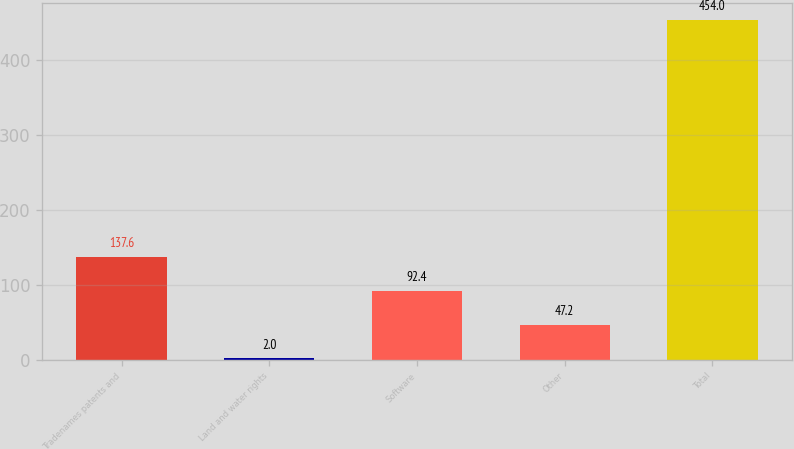Convert chart to OTSL. <chart><loc_0><loc_0><loc_500><loc_500><bar_chart><fcel>Tradenames patents and<fcel>Land and water rights<fcel>Software<fcel>Other<fcel>Total<nl><fcel>137.6<fcel>2<fcel>92.4<fcel>47.2<fcel>454<nl></chart> 